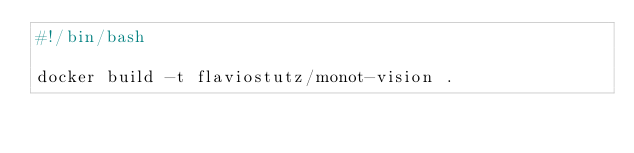<code> <loc_0><loc_0><loc_500><loc_500><_Bash_>#!/bin/bash

docker build -t flaviostutz/monot-vision .
</code> 